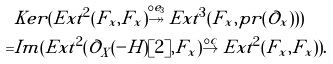<formula> <loc_0><loc_0><loc_500><loc_500>& K e r ( E x t ^ { 2 } ( F _ { x } , F _ { x } ) \stackrel { \circ e _ { 3 } } { \twoheadrightarrow } E x t ^ { 3 } ( F _ { x } , p r ( \mathcal { O } _ { x } ) ) ) \\ = & I m ( E x t ^ { 2 } ( \mathcal { O } _ { X } ( - H ) [ 2 ] , F _ { x } ) \stackrel { \circ c } { \to } E x t ^ { 2 } ( F _ { x } , F _ { x } ) ) .</formula> 